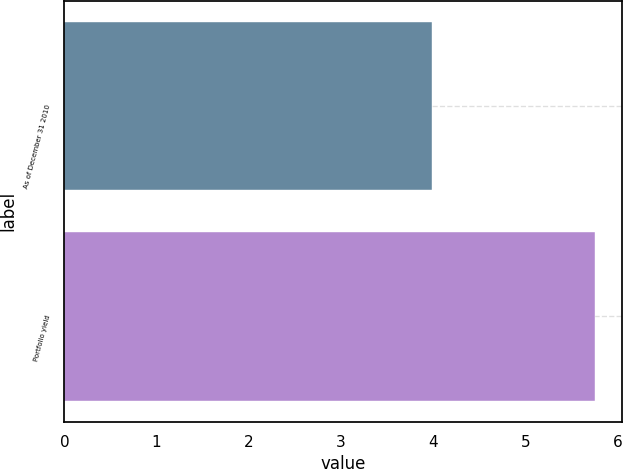Convert chart to OTSL. <chart><loc_0><loc_0><loc_500><loc_500><bar_chart><fcel>As of December 31 2010<fcel>Portfolio yield<nl><fcel>3.99<fcel>5.76<nl></chart> 